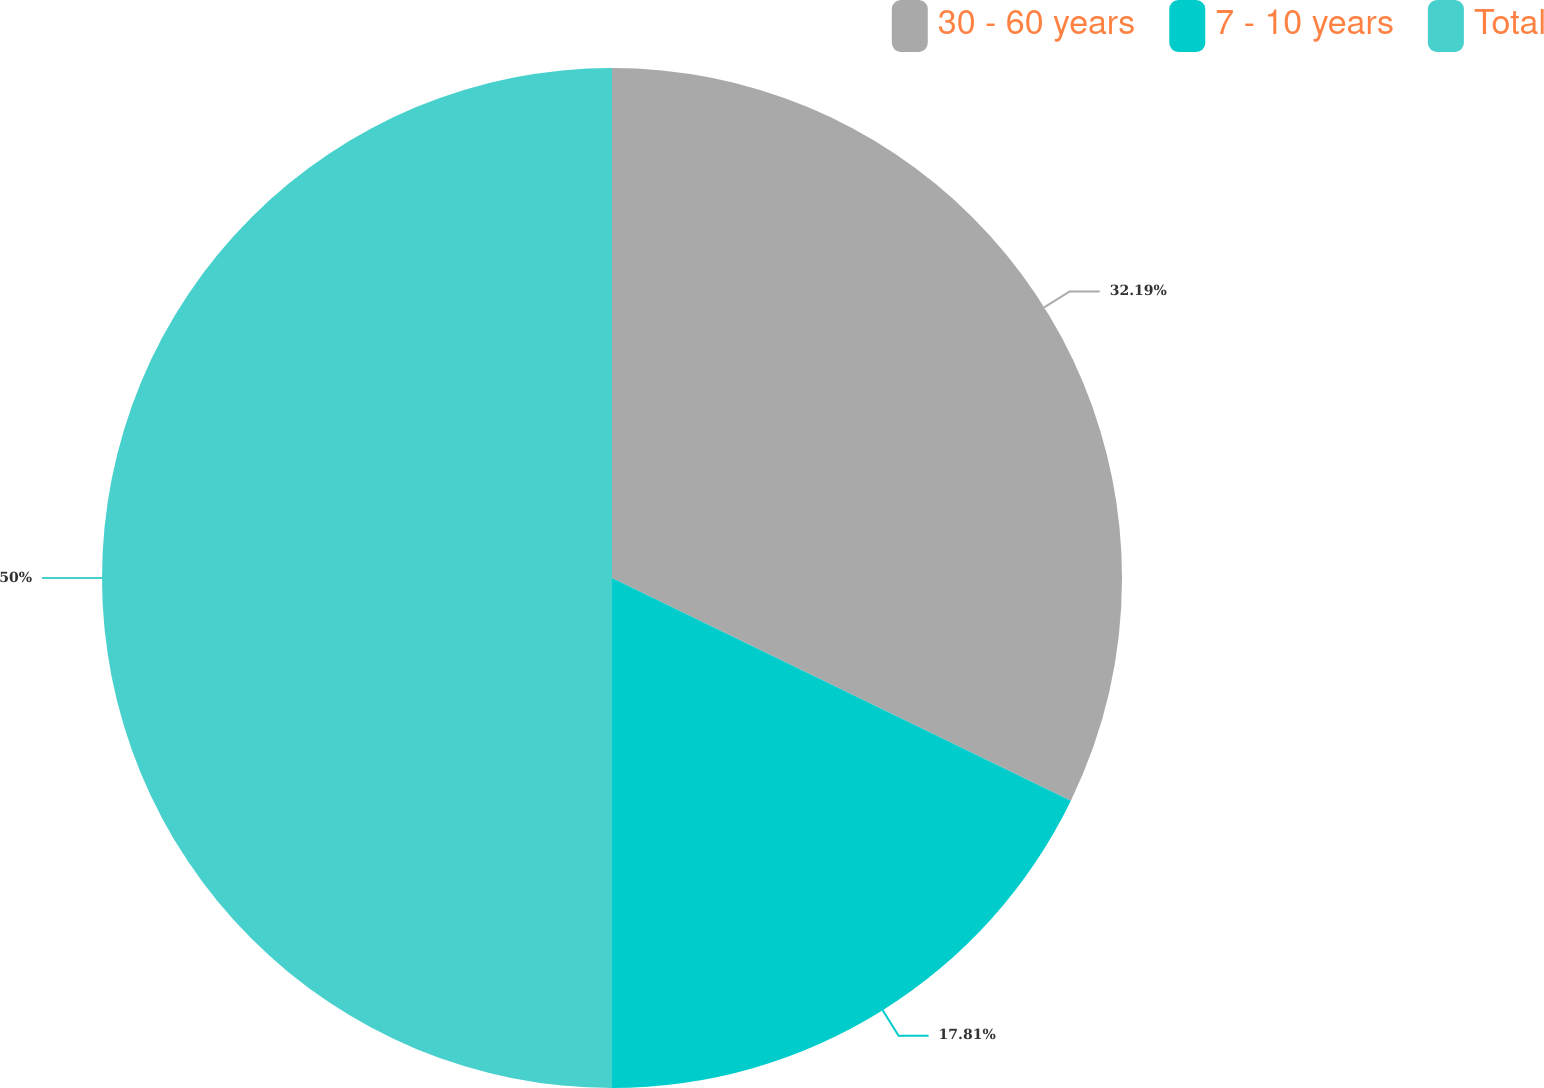Convert chart to OTSL. <chart><loc_0><loc_0><loc_500><loc_500><pie_chart><fcel>30 - 60 years<fcel>7 - 10 years<fcel>Total<nl><fcel>32.19%<fcel>17.81%<fcel>50.0%<nl></chart> 